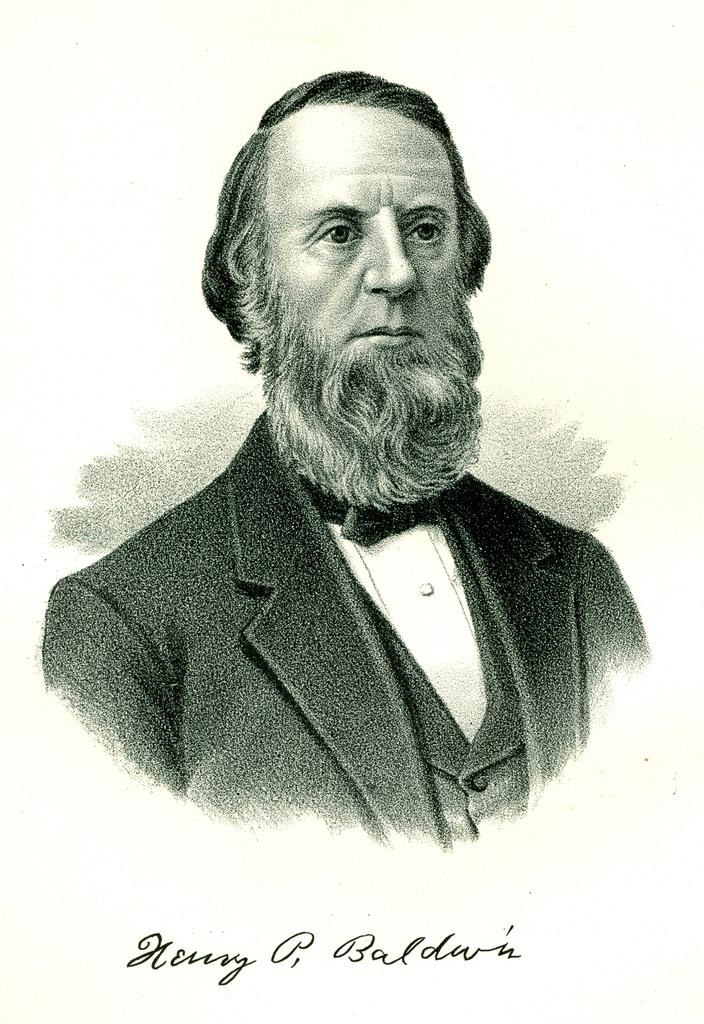What is the main subject of the image? The main subject of the image is a photo of a man. Can you describe any additional details about the photo? Yes, there is writing on the photo. Where is the carriage located in the image? There is no carriage present in the image. What type of snails can be seen in the photo? There are no snails present in the photo; it is a photo of a man with writing on it. 